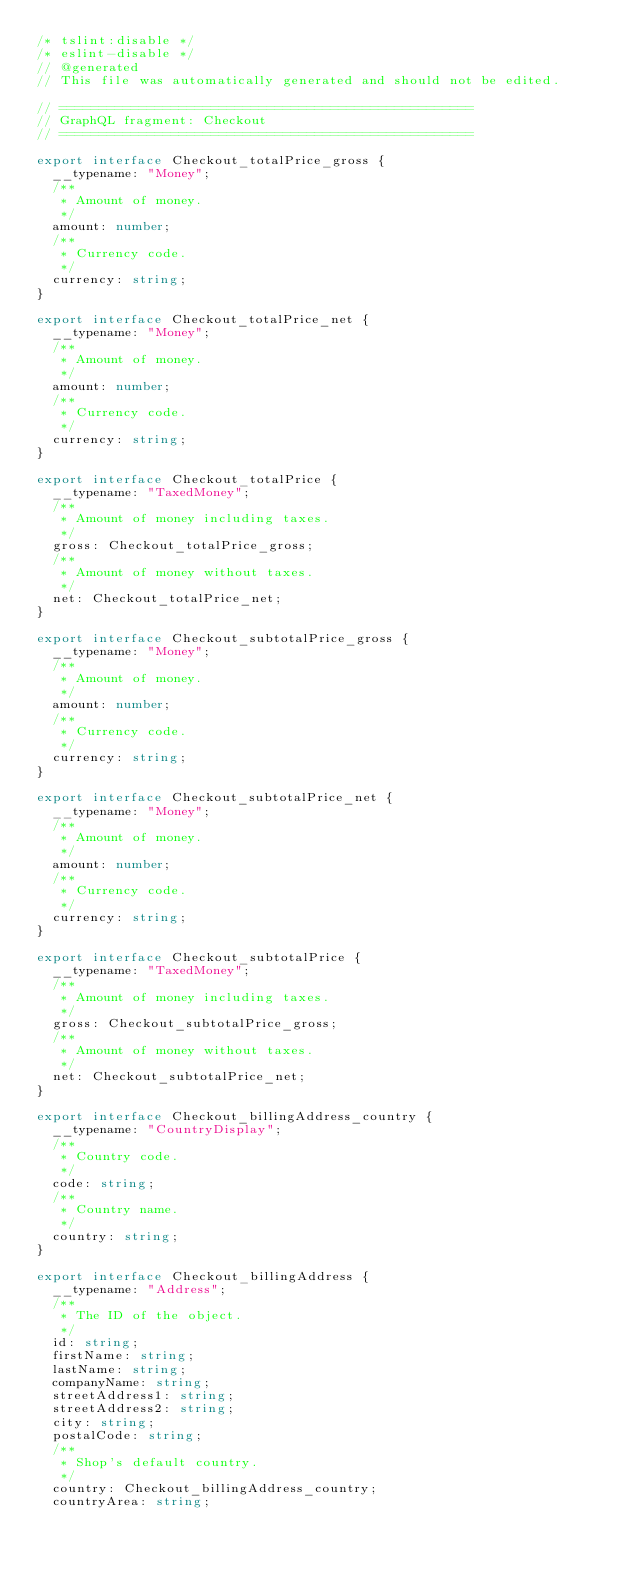Convert code to text. <code><loc_0><loc_0><loc_500><loc_500><_TypeScript_>/* tslint:disable */
/* eslint-disable */
// @generated
// This file was automatically generated and should not be edited.

// ====================================================
// GraphQL fragment: Checkout
// ====================================================

export interface Checkout_totalPrice_gross {
  __typename: "Money";
  /**
   * Amount of money.
   */
  amount: number;
  /**
   * Currency code.
   */
  currency: string;
}

export interface Checkout_totalPrice_net {
  __typename: "Money";
  /**
   * Amount of money.
   */
  amount: number;
  /**
   * Currency code.
   */
  currency: string;
}

export interface Checkout_totalPrice {
  __typename: "TaxedMoney";
  /**
   * Amount of money including taxes.
   */
  gross: Checkout_totalPrice_gross;
  /**
   * Amount of money without taxes.
   */
  net: Checkout_totalPrice_net;
}

export interface Checkout_subtotalPrice_gross {
  __typename: "Money";
  /**
   * Amount of money.
   */
  amount: number;
  /**
   * Currency code.
   */
  currency: string;
}

export interface Checkout_subtotalPrice_net {
  __typename: "Money";
  /**
   * Amount of money.
   */
  amount: number;
  /**
   * Currency code.
   */
  currency: string;
}

export interface Checkout_subtotalPrice {
  __typename: "TaxedMoney";
  /**
   * Amount of money including taxes.
   */
  gross: Checkout_subtotalPrice_gross;
  /**
   * Amount of money without taxes.
   */
  net: Checkout_subtotalPrice_net;
}

export interface Checkout_billingAddress_country {
  __typename: "CountryDisplay";
  /**
   * Country code.
   */
  code: string;
  /**
   * Country name.
   */
  country: string;
}

export interface Checkout_billingAddress {
  __typename: "Address";
  /**
   * The ID of the object.
   */
  id: string;
  firstName: string;
  lastName: string;
  companyName: string;
  streetAddress1: string;
  streetAddress2: string;
  city: string;
  postalCode: string;
  /**
   * Shop's default country.
   */
  country: Checkout_billingAddress_country;
  countryArea: string;</code> 